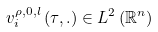Convert formula to latex. <formula><loc_0><loc_0><loc_500><loc_500>v ^ { \rho , 0 , l } _ { i } \left ( \tau , . \right ) \in L ^ { 2 } \left ( { \mathbb { R } } ^ { n } \right )</formula> 